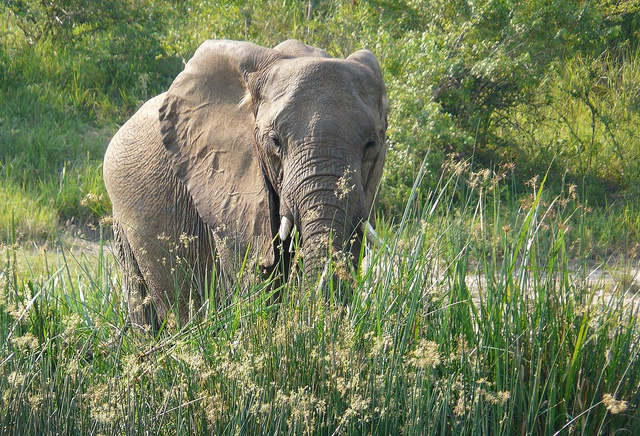Describe the objects in this image and their specific colors. I can see a elephant in darkgreen, gray, darkgray, and tan tones in this image. 